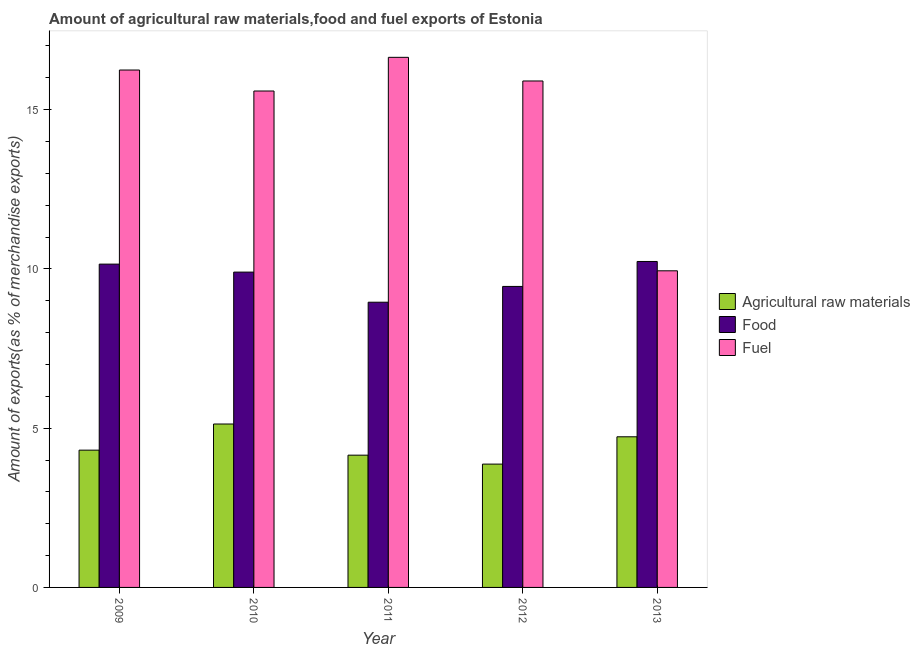How many different coloured bars are there?
Offer a terse response. 3. How many groups of bars are there?
Offer a terse response. 5. How many bars are there on the 1st tick from the right?
Provide a short and direct response. 3. In how many cases, is the number of bars for a given year not equal to the number of legend labels?
Offer a terse response. 0. What is the percentage of raw materials exports in 2011?
Offer a terse response. 4.15. Across all years, what is the maximum percentage of raw materials exports?
Provide a short and direct response. 5.13. Across all years, what is the minimum percentage of food exports?
Make the answer very short. 8.95. In which year was the percentage of raw materials exports minimum?
Provide a succinct answer. 2012. What is the total percentage of fuel exports in the graph?
Ensure brevity in your answer.  74.31. What is the difference between the percentage of food exports in 2011 and that in 2012?
Give a very brief answer. -0.5. What is the difference between the percentage of raw materials exports in 2011 and the percentage of fuel exports in 2009?
Ensure brevity in your answer.  -0.16. What is the average percentage of fuel exports per year?
Offer a very short reply. 14.86. In the year 2011, what is the difference between the percentage of fuel exports and percentage of food exports?
Provide a short and direct response. 0. In how many years, is the percentage of food exports greater than 11 %?
Give a very brief answer. 0. What is the ratio of the percentage of raw materials exports in 2009 to that in 2012?
Your response must be concise. 1.11. Is the percentage of fuel exports in 2011 less than that in 2013?
Provide a short and direct response. No. Is the difference between the percentage of raw materials exports in 2011 and 2013 greater than the difference between the percentage of fuel exports in 2011 and 2013?
Make the answer very short. No. What is the difference between the highest and the second highest percentage of fuel exports?
Offer a very short reply. 0.4. What is the difference between the highest and the lowest percentage of raw materials exports?
Offer a very short reply. 1.26. In how many years, is the percentage of raw materials exports greater than the average percentage of raw materials exports taken over all years?
Keep it short and to the point. 2. What does the 3rd bar from the left in 2011 represents?
Ensure brevity in your answer.  Fuel. What does the 2nd bar from the right in 2013 represents?
Provide a short and direct response. Food. Are all the bars in the graph horizontal?
Make the answer very short. No. What is the difference between two consecutive major ticks on the Y-axis?
Make the answer very short. 5. Does the graph contain any zero values?
Provide a short and direct response. No. How are the legend labels stacked?
Offer a terse response. Vertical. What is the title of the graph?
Keep it short and to the point. Amount of agricultural raw materials,food and fuel exports of Estonia. What is the label or title of the Y-axis?
Offer a very short reply. Amount of exports(as % of merchandise exports). What is the Amount of exports(as % of merchandise exports) in Agricultural raw materials in 2009?
Provide a short and direct response. 4.31. What is the Amount of exports(as % of merchandise exports) in Food in 2009?
Your answer should be very brief. 10.15. What is the Amount of exports(as % of merchandise exports) in Fuel in 2009?
Ensure brevity in your answer.  16.24. What is the Amount of exports(as % of merchandise exports) in Agricultural raw materials in 2010?
Make the answer very short. 5.13. What is the Amount of exports(as % of merchandise exports) of Food in 2010?
Provide a short and direct response. 9.9. What is the Amount of exports(as % of merchandise exports) of Fuel in 2010?
Offer a terse response. 15.58. What is the Amount of exports(as % of merchandise exports) of Agricultural raw materials in 2011?
Ensure brevity in your answer.  4.15. What is the Amount of exports(as % of merchandise exports) of Food in 2011?
Provide a short and direct response. 8.95. What is the Amount of exports(as % of merchandise exports) in Fuel in 2011?
Your response must be concise. 16.64. What is the Amount of exports(as % of merchandise exports) in Agricultural raw materials in 2012?
Your response must be concise. 3.87. What is the Amount of exports(as % of merchandise exports) in Food in 2012?
Make the answer very short. 9.45. What is the Amount of exports(as % of merchandise exports) in Fuel in 2012?
Your response must be concise. 15.9. What is the Amount of exports(as % of merchandise exports) of Agricultural raw materials in 2013?
Your answer should be compact. 4.73. What is the Amount of exports(as % of merchandise exports) in Food in 2013?
Make the answer very short. 10.23. What is the Amount of exports(as % of merchandise exports) in Fuel in 2013?
Your response must be concise. 9.94. Across all years, what is the maximum Amount of exports(as % of merchandise exports) of Agricultural raw materials?
Keep it short and to the point. 5.13. Across all years, what is the maximum Amount of exports(as % of merchandise exports) in Food?
Offer a very short reply. 10.23. Across all years, what is the maximum Amount of exports(as % of merchandise exports) in Fuel?
Keep it short and to the point. 16.64. Across all years, what is the minimum Amount of exports(as % of merchandise exports) of Agricultural raw materials?
Offer a terse response. 3.87. Across all years, what is the minimum Amount of exports(as % of merchandise exports) in Food?
Offer a very short reply. 8.95. Across all years, what is the minimum Amount of exports(as % of merchandise exports) in Fuel?
Offer a terse response. 9.94. What is the total Amount of exports(as % of merchandise exports) in Agricultural raw materials in the graph?
Your answer should be compact. 22.19. What is the total Amount of exports(as % of merchandise exports) in Food in the graph?
Provide a succinct answer. 48.68. What is the total Amount of exports(as % of merchandise exports) of Fuel in the graph?
Provide a succinct answer. 74.31. What is the difference between the Amount of exports(as % of merchandise exports) of Agricultural raw materials in 2009 and that in 2010?
Offer a very short reply. -0.82. What is the difference between the Amount of exports(as % of merchandise exports) of Food in 2009 and that in 2010?
Your answer should be compact. 0.25. What is the difference between the Amount of exports(as % of merchandise exports) in Fuel in 2009 and that in 2010?
Offer a terse response. 0.66. What is the difference between the Amount of exports(as % of merchandise exports) of Agricultural raw materials in 2009 and that in 2011?
Ensure brevity in your answer.  0.16. What is the difference between the Amount of exports(as % of merchandise exports) of Food in 2009 and that in 2011?
Your answer should be compact. 1.2. What is the difference between the Amount of exports(as % of merchandise exports) in Fuel in 2009 and that in 2011?
Make the answer very short. -0.4. What is the difference between the Amount of exports(as % of merchandise exports) of Agricultural raw materials in 2009 and that in 2012?
Your answer should be compact. 0.44. What is the difference between the Amount of exports(as % of merchandise exports) in Food in 2009 and that in 2012?
Provide a succinct answer. 0.7. What is the difference between the Amount of exports(as % of merchandise exports) in Fuel in 2009 and that in 2012?
Offer a very short reply. 0.34. What is the difference between the Amount of exports(as % of merchandise exports) of Agricultural raw materials in 2009 and that in 2013?
Provide a succinct answer. -0.42. What is the difference between the Amount of exports(as % of merchandise exports) in Food in 2009 and that in 2013?
Provide a short and direct response. -0.08. What is the difference between the Amount of exports(as % of merchandise exports) in Fuel in 2009 and that in 2013?
Your answer should be very brief. 6.3. What is the difference between the Amount of exports(as % of merchandise exports) in Agricultural raw materials in 2010 and that in 2011?
Your answer should be very brief. 0.98. What is the difference between the Amount of exports(as % of merchandise exports) in Food in 2010 and that in 2011?
Your answer should be compact. 0.95. What is the difference between the Amount of exports(as % of merchandise exports) in Fuel in 2010 and that in 2011?
Offer a terse response. -1.06. What is the difference between the Amount of exports(as % of merchandise exports) in Agricultural raw materials in 2010 and that in 2012?
Ensure brevity in your answer.  1.26. What is the difference between the Amount of exports(as % of merchandise exports) in Food in 2010 and that in 2012?
Give a very brief answer. 0.45. What is the difference between the Amount of exports(as % of merchandise exports) in Fuel in 2010 and that in 2012?
Provide a succinct answer. -0.31. What is the difference between the Amount of exports(as % of merchandise exports) in Agricultural raw materials in 2010 and that in 2013?
Ensure brevity in your answer.  0.4. What is the difference between the Amount of exports(as % of merchandise exports) in Food in 2010 and that in 2013?
Your response must be concise. -0.33. What is the difference between the Amount of exports(as % of merchandise exports) in Fuel in 2010 and that in 2013?
Ensure brevity in your answer.  5.64. What is the difference between the Amount of exports(as % of merchandise exports) in Agricultural raw materials in 2011 and that in 2012?
Your answer should be compact. 0.28. What is the difference between the Amount of exports(as % of merchandise exports) of Food in 2011 and that in 2012?
Your answer should be compact. -0.5. What is the difference between the Amount of exports(as % of merchandise exports) of Fuel in 2011 and that in 2012?
Offer a very short reply. 0.74. What is the difference between the Amount of exports(as % of merchandise exports) of Agricultural raw materials in 2011 and that in 2013?
Provide a short and direct response. -0.58. What is the difference between the Amount of exports(as % of merchandise exports) of Food in 2011 and that in 2013?
Provide a short and direct response. -1.28. What is the difference between the Amount of exports(as % of merchandise exports) in Fuel in 2011 and that in 2013?
Provide a succinct answer. 6.7. What is the difference between the Amount of exports(as % of merchandise exports) of Agricultural raw materials in 2012 and that in 2013?
Provide a succinct answer. -0.86. What is the difference between the Amount of exports(as % of merchandise exports) of Food in 2012 and that in 2013?
Provide a succinct answer. -0.78. What is the difference between the Amount of exports(as % of merchandise exports) in Fuel in 2012 and that in 2013?
Provide a short and direct response. 5.96. What is the difference between the Amount of exports(as % of merchandise exports) of Agricultural raw materials in 2009 and the Amount of exports(as % of merchandise exports) of Food in 2010?
Make the answer very short. -5.59. What is the difference between the Amount of exports(as % of merchandise exports) of Agricultural raw materials in 2009 and the Amount of exports(as % of merchandise exports) of Fuel in 2010?
Ensure brevity in your answer.  -11.27. What is the difference between the Amount of exports(as % of merchandise exports) in Food in 2009 and the Amount of exports(as % of merchandise exports) in Fuel in 2010?
Make the answer very short. -5.43. What is the difference between the Amount of exports(as % of merchandise exports) in Agricultural raw materials in 2009 and the Amount of exports(as % of merchandise exports) in Food in 2011?
Provide a succinct answer. -4.64. What is the difference between the Amount of exports(as % of merchandise exports) of Agricultural raw materials in 2009 and the Amount of exports(as % of merchandise exports) of Fuel in 2011?
Your response must be concise. -12.33. What is the difference between the Amount of exports(as % of merchandise exports) in Food in 2009 and the Amount of exports(as % of merchandise exports) in Fuel in 2011?
Make the answer very short. -6.49. What is the difference between the Amount of exports(as % of merchandise exports) in Agricultural raw materials in 2009 and the Amount of exports(as % of merchandise exports) in Food in 2012?
Give a very brief answer. -5.14. What is the difference between the Amount of exports(as % of merchandise exports) in Agricultural raw materials in 2009 and the Amount of exports(as % of merchandise exports) in Fuel in 2012?
Provide a succinct answer. -11.59. What is the difference between the Amount of exports(as % of merchandise exports) in Food in 2009 and the Amount of exports(as % of merchandise exports) in Fuel in 2012?
Your answer should be compact. -5.75. What is the difference between the Amount of exports(as % of merchandise exports) of Agricultural raw materials in 2009 and the Amount of exports(as % of merchandise exports) of Food in 2013?
Provide a succinct answer. -5.92. What is the difference between the Amount of exports(as % of merchandise exports) in Agricultural raw materials in 2009 and the Amount of exports(as % of merchandise exports) in Fuel in 2013?
Keep it short and to the point. -5.63. What is the difference between the Amount of exports(as % of merchandise exports) of Food in 2009 and the Amount of exports(as % of merchandise exports) of Fuel in 2013?
Provide a short and direct response. 0.21. What is the difference between the Amount of exports(as % of merchandise exports) in Agricultural raw materials in 2010 and the Amount of exports(as % of merchandise exports) in Food in 2011?
Make the answer very short. -3.82. What is the difference between the Amount of exports(as % of merchandise exports) of Agricultural raw materials in 2010 and the Amount of exports(as % of merchandise exports) of Fuel in 2011?
Give a very brief answer. -11.51. What is the difference between the Amount of exports(as % of merchandise exports) of Food in 2010 and the Amount of exports(as % of merchandise exports) of Fuel in 2011?
Provide a short and direct response. -6.74. What is the difference between the Amount of exports(as % of merchandise exports) of Agricultural raw materials in 2010 and the Amount of exports(as % of merchandise exports) of Food in 2012?
Your response must be concise. -4.32. What is the difference between the Amount of exports(as % of merchandise exports) of Agricultural raw materials in 2010 and the Amount of exports(as % of merchandise exports) of Fuel in 2012?
Offer a terse response. -10.77. What is the difference between the Amount of exports(as % of merchandise exports) in Agricultural raw materials in 2010 and the Amount of exports(as % of merchandise exports) in Food in 2013?
Your answer should be very brief. -5.1. What is the difference between the Amount of exports(as % of merchandise exports) in Agricultural raw materials in 2010 and the Amount of exports(as % of merchandise exports) in Fuel in 2013?
Offer a terse response. -4.81. What is the difference between the Amount of exports(as % of merchandise exports) of Food in 2010 and the Amount of exports(as % of merchandise exports) of Fuel in 2013?
Your answer should be compact. -0.04. What is the difference between the Amount of exports(as % of merchandise exports) of Agricultural raw materials in 2011 and the Amount of exports(as % of merchandise exports) of Food in 2012?
Make the answer very short. -5.3. What is the difference between the Amount of exports(as % of merchandise exports) of Agricultural raw materials in 2011 and the Amount of exports(as % of merchandise exports) of Fuel in 2012?
Offer a very short reply. -11.75. What is the difference between the Amount of exports(as % of merchandise exports) of Food in 2011 and the Amount of exports(as % of merchandise exports) of Fuel in 2012?
Offer a terse response. -6.95. What is the difference between the Amount of exports(as % of merchandise exports) of Agricultural raw materials in 2011 and the Amount of exports(as % of merchandise exports) of Food in 2013?
Provide a succinct answer. -6.08. What is the difference between the Amount of exports(as % of merchandise exports) in Agricultural raw materials in 2011 and the Amount of exports(as % of merchandise exports) in Fuel in 2013?
Ensure brevity in your answer.  -5.79. What is the difference between the Amount of exports(as % of merchandise exports) in Food in 2011 and the Amount of exports(as % of merchandise exports) in Fuel in 2013?
Your answer should be very brief. -0.99. What is the difference between the Amount of exports(as % of merchandise exports) in Agricultural raw materials in 2012 and the Amount of exports(as % of merchandise exports) in Food in 2013?
Provide a short and direct response. -6.36. What is the difference between the Amount of exports(as % of merchandise exports) in Agricultural raw materials in 2012 and the Amount of exports(as % of merchandise exports) in Fuel in 2013?
Your answer should be compact. -6.07. What is the difference between the Amount of exports(as % of merchandise exports) of Food in 2012 and the Amount of exports(as % of merchandise exports) of Fuel in 2013?
Provide a succinct answer. -0.49. What is the average Amount of exports(as % of merchandise exports) in Agricultural raw materials per year?
Offer a very short reply. 4.44. What is the average Amount of exports(as % of merchandise exports) in Food per year?
Keep it short and to the point. 9.74. What is the average Amount of exports(as % of merchandise exports) in Fuel per year?
Provide a succinct answer. 14.86. In the year 2009, what is the difference between the Amount of exports(as % of merchandise exports) of Agricultural raw materials and Amount of exports(as % of merchandise exports) of Food?
Provide a short and direct response. -5.84. In the year 2009, what is the difference between the Amount of exports(as % of merchandise exports) of Agricultural raw materials and Amount of exports(as % of merchandise exports) of Fuel?
Give a very brief answer. -11.93. In the year 2009, what is the difference between the Amount of exports(as % of merchandise exports) in Food and Amount of exports(as % of merchandise exports) in Fuel?
Your answer should be very brief. -6.09. In the year 2010, what is the difference between the Amount of exports(as % of merchandise exports) in Agricultural raw materials and Amount of exports(as % of merchandise exports) in Food?
Your response must be concise. -4.77. In the year 2010, what is the difference between the Amount of exports(as % of merchandise exports) of Agricultural raw materials and Amount of exports(as % of merchandise exports) of Fuel?
Your answer should be very brief. -10.45. In the year 2010, what is the difference between the Amount of exports(as % of merchandise exports) of Food and Amount of exports(as % of merchandise exports) of Fuel?
Your answer should be compact. -5.69. In the year 2011, what is the difference between the Amount of exports(as % of merchandise exports) in Agricultural raw materials and Amount of exports(as % of merchandise exports) in Food?
Ensure brevity in your answer.  -4.8. In the year 2011, what is the difference between the Amount of exports(as % of merchandise exports) in Agricultural raw materials and Amount of exports(as % of merchandise exports) in Fuel?
Your response must be concise. -12.49. In the year 2011, what is the difference between the Amount of exports(as % of merchandise exports) of Food and Amount of exports(as % of merchandise exports) of Fuel?
Ensure brevity in your answer.  -7.69. In the year 2012, what is the difference between the Amount of exports(as % of merchandise exports) of Agricultural raw materials and Amount of exports(as % of merchandise exports) of Food?
Your answer should be very brief. -5.58. In the year 2012, what is the difference between the Amount of exports(as % of merchandise exports) in Agricultural raw materials and Amount of exports(as % of merchandise exports) in Fuel?
Your answer should be compact. -12.03. In the year 2012, what is the difference between the Amount of exports(as % of merchandise exports) of Food and Amount of exports(as % of merchandise exports) of Fuel?
Provide a succinct answer. -6.45. In the year 2013, what is the difference between the Amount of exports(as % of merchandise exports) of Agricultural raw materials and Amount of exports(as % of merchandise exports) of Food?
Keep it short and to the point. -5.5. In the year 2013, what is the difference between the Amount of exports(as % of merchandise exports) of Agricultural raw materials and Amount of exports(as % of merchandise exports) of Fuel?
Ensure brevity in your answer.  -5.21. In the year 2013, what is the difference between the Amount of exports(as % of merchandise exports) of Food and Amount of exports(as % of merchandise exports) of Fuel?
Your answer should be very brief. 0.29. What is the ratio of the Amount of exports(as % of merchandise exports) of Agricultural raw materials in 2009 to that in 2010?
Your response must be concise. 0.84. What is the ratio of the Amount of exports(as % of merchandise exports) in Food in 2009 to that in 2010?
Your response must be concise. 1.03. What is the ratio of the Amount of exports(as % of merchandise exports) of Fuel in 2009 to that in 2010?
Provide a succinct answer. 1.04. What is the ratio of the Amount of exports(as % of merchandise exports) of Agricultural raw materials in 2009 to that in 2011?
Ensure brevity in your answer.  1.04. What is the ratio of the Amount of exports(as % of merchandise exports) of Food in 2009 to that in 2011?
Make the answer very short. 1.13. What is the ratio of the Amount of exports(as % of merchandise exports) of Fuel in 2009 to that in 2011?
Provide a succinct answer. 0.98. What is the ratio of the Amount of exports(as % of merchandise exports) in Agricultural raw materials in 2009 to that in 2012?
Your answer should be compact. 1.11. What is the ratio of the Amount of exports(as % of merchandise exports) of Food in 2009 to that in 2012?
Your answer should be compact. 1.07. What is the ratio of the Amount of exports(as % of merchandise exports) of Fuel in 2009 to that in 2012?
Your answer should be compact. 1.02. What is the ratio of the Amount of exports(as % of merchandise exports) of Agricultural raw materials in 2009 to that in 2013?
Your answer should be compact. 0.91. What is the ratio of the Amount of exports(as % of merchandise exports) of Fuel in 2009 to that in 2013?
Make the answer very short. 1.63. What is the ratio of the Amount of exports(as % of merchandise exports) of Agricultural raw materials in 2010 to that in 2011?
Your answer should be compact. 1.24. What is the ratio of the Amount of exports(as % of merchandise exports) of Food in 2010 to that in 2011?
Offer a terse response. 1.11. What is the ratio of the Amount of exports(as % of merchandise exports) of Fuel in 2010 to that in 2011?
Ensure brevity in your answer.  0.94. What is the ratio of the Amount of exports(as % of merchandise exports) of Agricultural raw materials in 2010 to that in 2012?
Give a very brief answer. 1.33. What is the ratio of the Amount of exports(as % of merchandise exports) in Food in 2010 to that in 2012?
Keep it short and to the point. 1.05. What is the ratio of the Amount of exports(as % of merchandise exports) in Fuel in 2010 to that in 2012?
Provide a short and direct response. 0.98. What is the ratio of the Amount of exports(as % of merchandise exports) in Agricultural raw materials in 2010 to that in 2013?
Your answer should be very brief. 1.08. What is the ratio of the Amount of exports(as % of merchandise exports) of Food in 2010 to that in 2013?
Keep it short and to the point. 0.97. What is the ratio of the Amount of exports(as % of merchandise exports) of Fuel in 2010 to that in 2013?
Provide a succinct answer. 1.57. What is the ratio of the Amount of exports(as % of merchandise exports) in Agricultural raw materials in 2011 to that in 2012?
Offer a very short reply. 1.07. What is the ratio of the Amount of exports(as % of merchandise exports) in Food in 2011 to that in 2012?
Ensure brevity in your answer.  0.95. What is the ratio of the Amount of exports(as % of merchandise exports) in Fuel in 2011 to that in 2012?
Offer a very short reply. 1.05. What is the ratio of the Amount of exports(as % of merchandise exports) of Agricultural raw materials in 2011 to that in 2013?
Ensure brevity in your answer.  0.88. What is the ratio of the Amount of exports(as % of merchandise exports) of Fuel in 2011 to that in 2013?
Your response must be concise. 1.67. What is the ratio of the Amount of exports(as % of merchandise exports) in Agricultural raw materials in 2012 to that in 2013?
Provide a short and direct response. 0.82. What is the ratio of the Amount of exports(as % of merchandise exports) of Food in 2012 to that in 2013?
Offer a terse response. 0.92. What is the ratio of the Amount of exports(as % of merchandise exports) in Fuel in 2012 to that in 2013?
Make the answer very short. 1.6. What is the difference between the highest and the second highest Amount of exports(as % of merchandise exports) in Agricultural raw materials?
Keep it short and to the point. 0.4. What is the difference between the highest and the second highest Amount of exports(as % of merchandise exports) in Food?
Offer a very short reply. 0.08. What is the difference between the highest and the second highest Amount of exports(as % of merchandise exports) of Fuel?
Your answer should be compact. 0.4. What is the difference between the highest and the lowest Amount of exports(as % of merchandise exports) in Agricultural raw materials?
Provide a short and direct response. 1.26. What is the difference between the highest and the lowest Amount of exports(as % of merchandise exports) of Food?
Provide a short and direct response. 1.28. What is the difference between the highest and the lowest Amount of exports(as % of merchandise exports) of Fuel?
Keep it short and to the point. 6.7. 